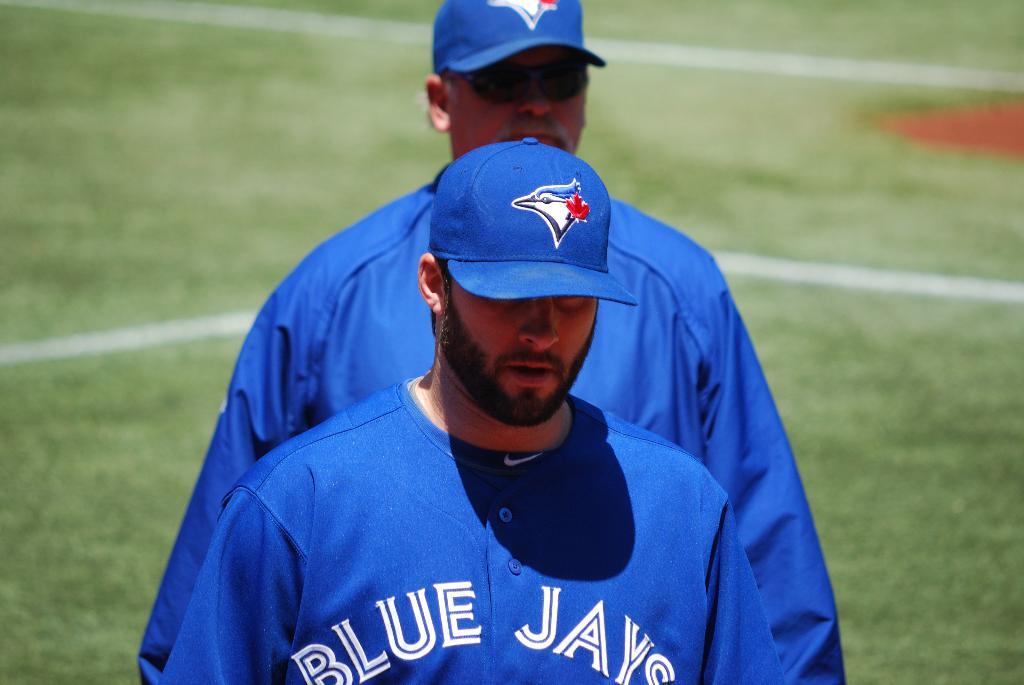How many people are in the image? There are two men in the image. What are the men wearing on their upper bodies? Both men are wearing blue t-shirts. What type of headwear are the men wearing? Both men are wearing caps. Can you describe the background of the image? The background of the image is blurry. What type of vegetation is visible in the background? There is grass visible in the background of the image. What type of music can be heard playing in the background of the image? There is no music present in the image; it is a still photograph of two men. 